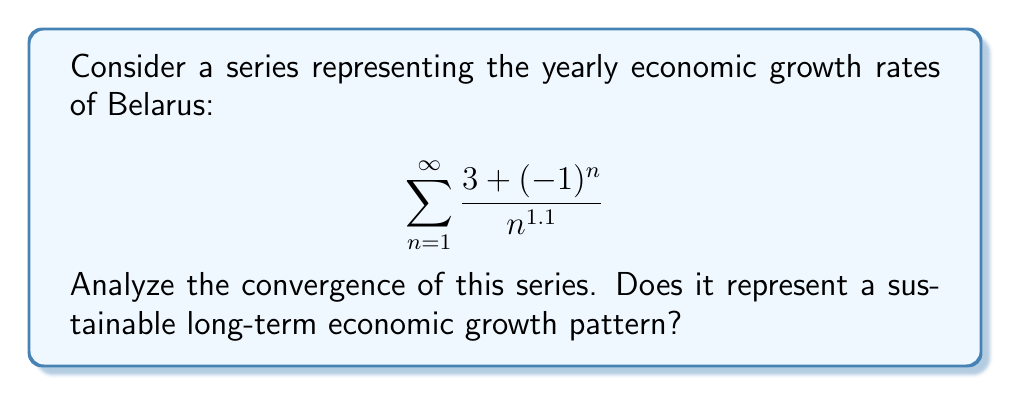Can you answer this question? To analyze the convergence of this series, we'll use the limit comparison test with a p-series.

Step 1: Identify the general term of the series
$$a_n = \frac{3 + (-1)^n}{n^{1.1}}$$

Step 2: Find the limit of the absolute value of the general term
$$\lim_{n \to \infty} |a_n| = \lim_{n \to \infty} \left|\frac{3 + (-1)^n}{n^{1.1}}\right|$$

Step 3: Compare with a p-series
Let's compare with $\frac{1}{n^{1.1}}$

$$\lim_{n \to \infty} \frac{|a_n|}{\frac{1}{n^{1.1}}} = \lim_{n \to \infty} \frac{\left|\frac{3 + (-1)^n}{n^{1.1}}\right|}{\frac{1}{n^{1.1}}} = \lim_{n \to \infty} |3 + (-1)^n|$$

Step 4: Evaluate the limit
The limit oscillates between 2 and 4, but is always finite and non-zero.

Step 5: Apply the limit comparison test
Since the limit is finite and non-zero, our series converges if and only if $\sum \frac{1}{n^{1.1}}$ converges.

Step 6: Check convergence of $\sum \frac{1}{n^{1.1}}$
This is a p-series with $p = 1.1 > 1$, so it converges.

Therefore, the original series converges.

Economic interpretation: The convergence of the series suggests that the sum of all growth rates is finite. This implies that the long-term average growth rate approaches zero, indicating a slowdown in economic growth over time. While not necessarily unsustainable, it suggests a transition to a more stable, mature economy rather than continuous rapid expansion.
Answer: The series converges, implying a finite sum of growth rates and a long-term slowdown in economic growth. 